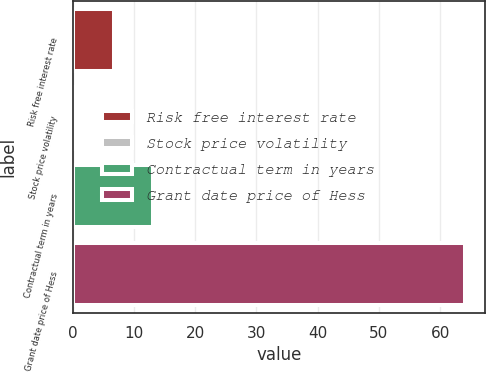Convert chart to OTSL. <chart><loc_0><loc_0><loc_500><loc_500><bar_chart><fcel>Risk free interest rate<fcel>Stock price volatility<fcel>Contractual term in years<fcel>Grant date price of Hess<nl><fcel>6.76<fcel>0.39<fcel>13.13<fcel>64.14<nl></chart> 